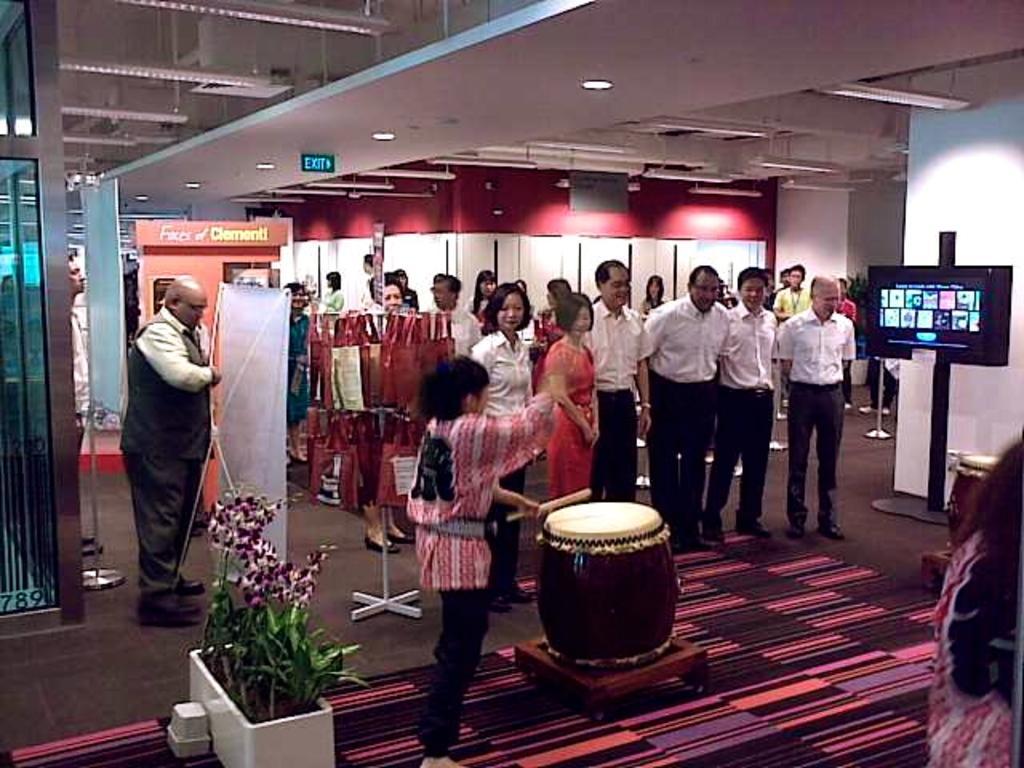Describe this image in one or two sentences. Here we can see some persons are standing on the floor. This is drum. Here we can see a banner and there is a plant. There is a screen and this is wall. And these are the lights. 